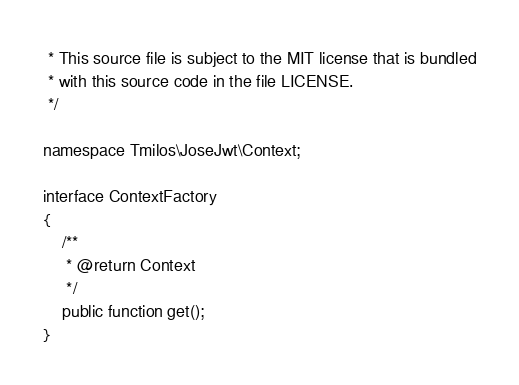Convert code to text. <code><loc_0><loc_0><loc_500><loc_500><_PHP_> * This source file is subject to the MIT license that is bundled
 * with this source code in the file LICENSE.
 */

namespace Tmilos\JoseJwt\Context;

interface ContextFactory
{
    /**
     * @return Context
     */
    public function get();
}
</code> 